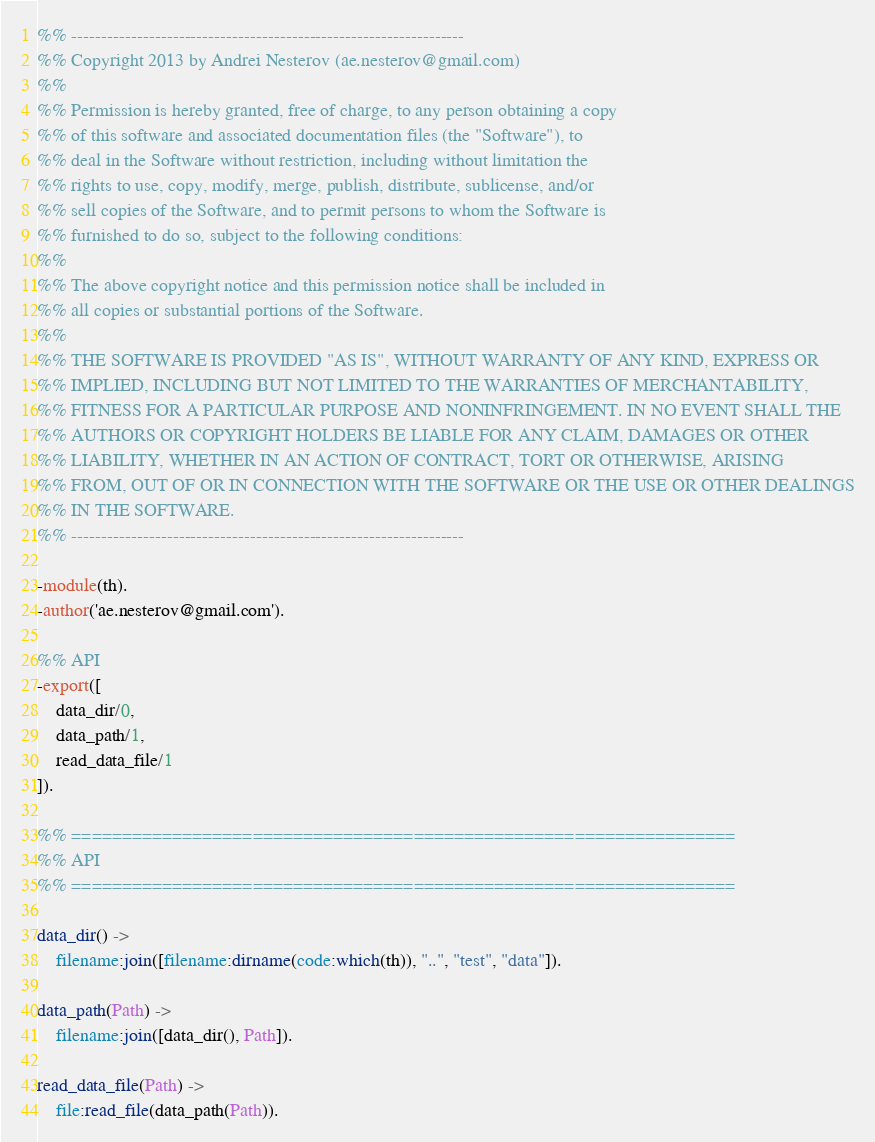<code> <loc_0><loc_0><loc_500><loc_500><_Erlang_>%% ------------------------------------------------------------------
%% Copyright 2013 by Andrei Nesterov (ae.nesterov@gmail.com)
%%
%% Permission is hereby granted, free of charge, to any person obtaining a copy
%% of this software and associated documentation files (the "Software"), to
%% deal in the Software without restriction, including without limitation the
%% rights to use, copy, modify, merge, publish, distribute, sublicense, and/or
%% sell copies of the Software, and to permit persons to whom the Software is
%% furnished to do so, subject to the following conditions:
%%
%% The above copyright notice and this permission notice shall be included in
%% all copies or substantial portions of the Software.
%%
%% THE SOFTWARE IS PROVIDED "AS IS", WITHOUT WARRANTY OF ANY KIND, EXPRESS OR
%% IMPLIED, INCLUDING BUT NOT LIMITED TO THE WARRANTIES OF MERCHANTABILITY,
%% FITNESS FOR A PARTICULAR PURPOSE AND NONINFRINGEMENT. IN NO EVENT SHALL THE
%% AUTHORS OR COPYRIGHT HOLDERS BE LIABLE FOR ANY CLAIM, DAMAGES OR OTHER
%% LIABILITY, WHETHER IN AN ACTION OF CONTRACT, TORT OR OTHERWISE, ARISING
%% FROM, OUT OF OR IN CONNECTION WITH THE SOFTWARE OR THE USE OR OTHER DEALINGS
%% IN THE SOFTWARE.
%% ------------------------------------------------------------------

-module(th).
-author('ae.nesterov@gmail.com').

%% API
-export([
	data_dir/0,
	data_path/1,
	read_data_file/1
]).

%% ==================================================================
%% API
%% ==================================================================

data_dir() ->
	filename:join([filename:dirname(code:which(th)), "..", "test", "data"]).

data_path(Path) ->
	filename:join([data_dir(), Path]).

read_data_file(Path) ->
	file:read_file(data_path(Path)).

</code> 